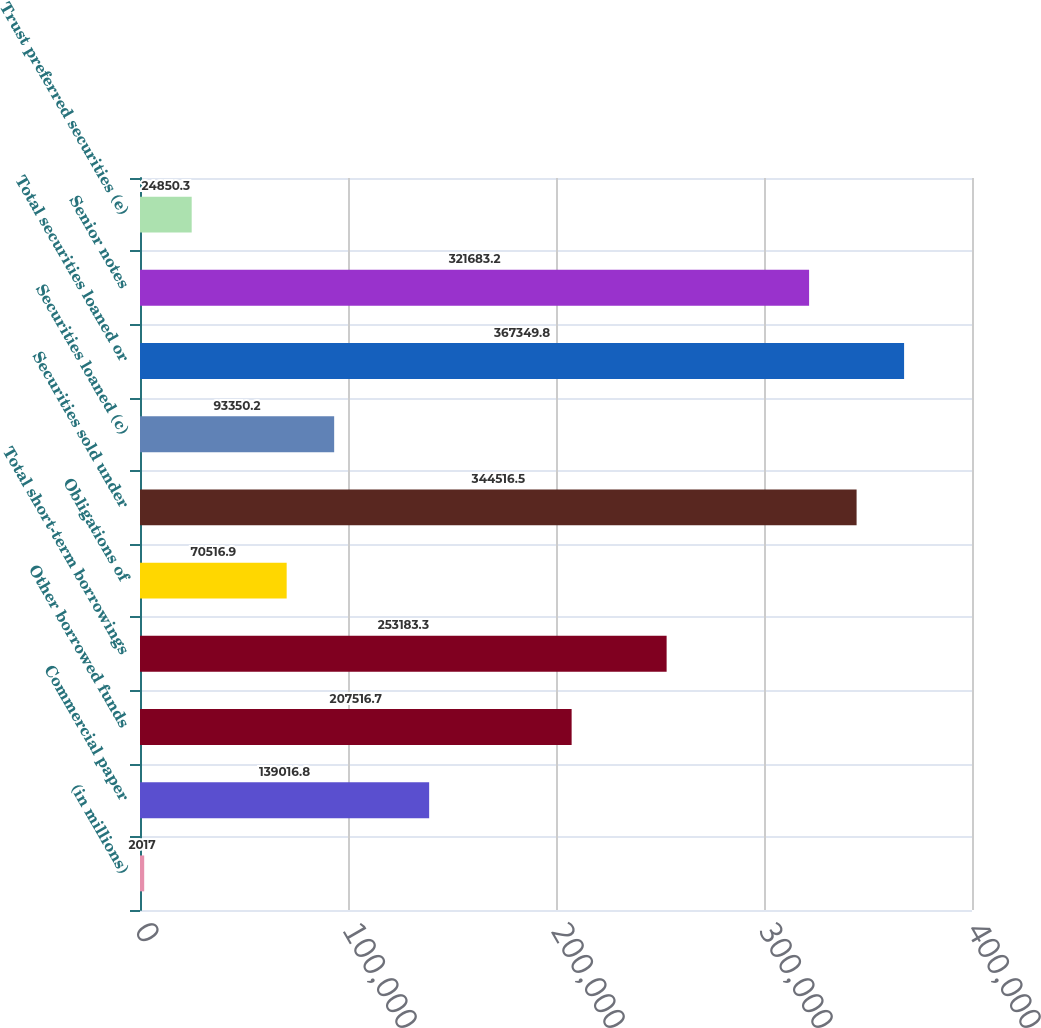<chart> <loc_0><loc_0><loc_500><loc_500><bar_chart><fcel>(in millions)<fcel>Commercial paper<fcel>Other borrowed funds<fcel>Total short-term borrowings<fcel>Obligations of<fcel>Securities sold under<fcel>Securities loaned (c)<fcel>Total securities loaned or<fcel>Senior notes<fcel>Trust preferred securities (e)<nl><fcel>2017<fcel>139017<fcel>207517<fcel>253183<fcel>70516.9<fcel>344516<fcel>93350.2<fcel>367350<fcel>321683<fcel>24850.3<nl></chart> 